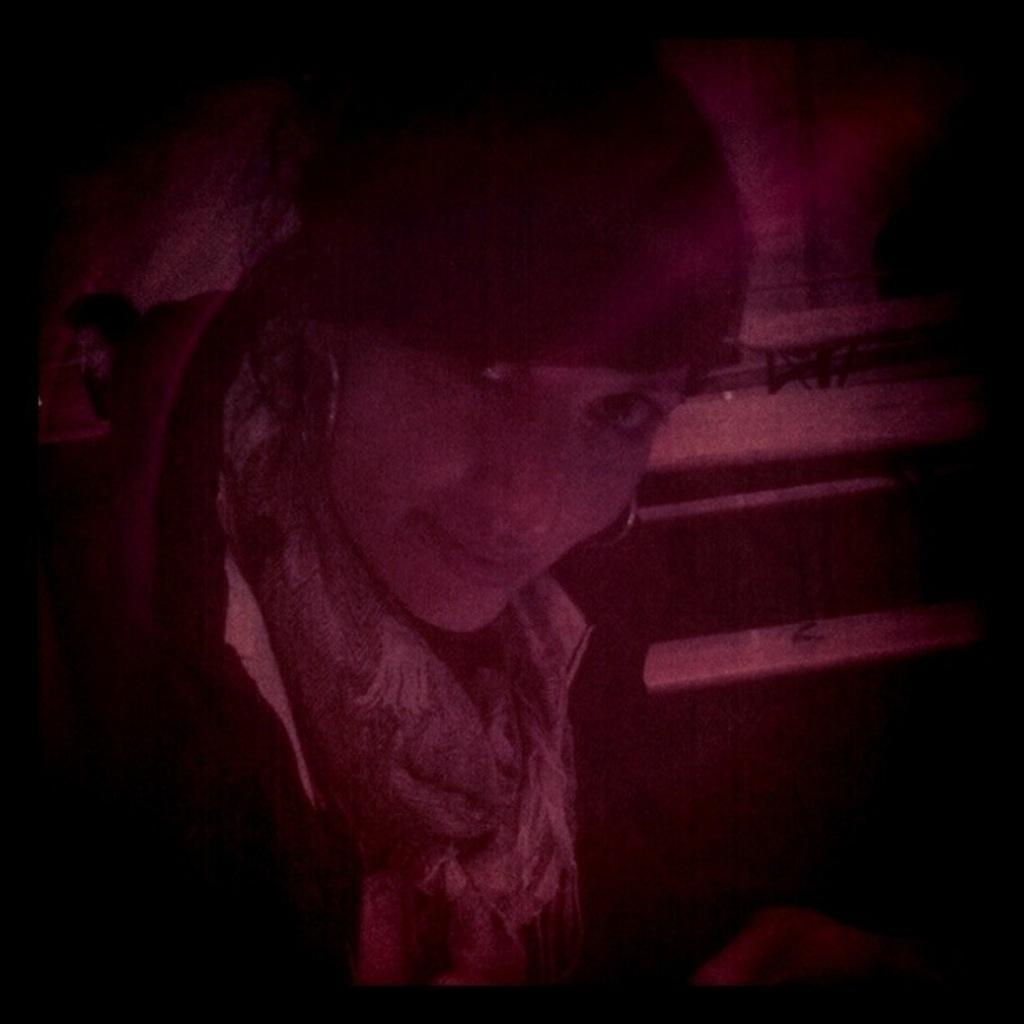Could you give a brief overview of what you see in this image? This is an image clicked in the dark. In this image I can see a woman is looking at the picture. The background is in black color. 